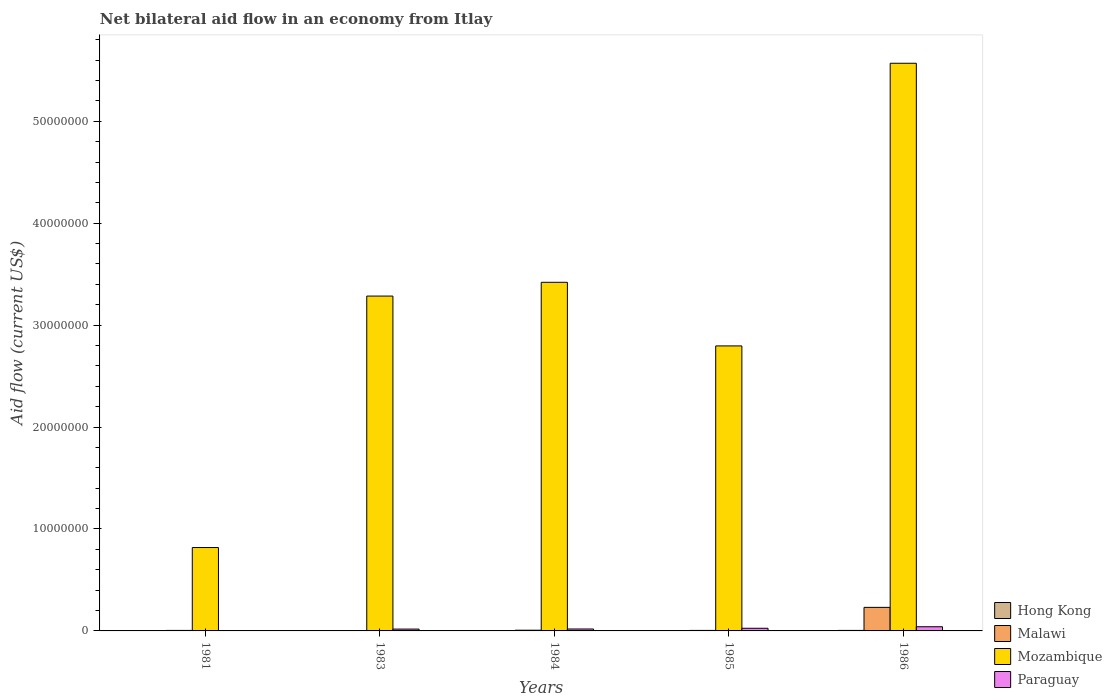How many different coloured bars are there?
Keep it short and to the point. 4. How many groups of bars are there?
Offer a very short reply. 5. Are the number of bars per tick equal to the number of legend labels?
Provide a succinct answer. Yes. How many bars are there on the 2nd tick from the right?
Your answer should be very brief. 4. What is the label of the 3rd group of bars from the left?
Offer a terse response. 1984. In how many cases, is the number of bars for a given year not equal to the number of legend labels?
Your answer should be compact. 0. Across all years, what is the minimum net bilateral aid flow in Hong Kong?
Give a very brief answer. 10000. In which year was the net bilateral aid flow in Paraguay minimum?
Provide a short and direct response. 1981. What is the total net bilateral aid flow in Hong Kong in the graph?
Provide a succinct answer. 1.10e+05. What is the difference between the net bilateral aid flow in Malawi in 1985 and that in 1986?
Provide a short and direct response. -2.26e+06. What is the difference between the net bilateral aid flow in Paraguay in 1986 and the net bilateral aid flow in Mozambique in 1985?
Keep it short and to the point. -2.76e+07. What is the average net bilateral aid flow in Hong Kong per year?
Provide a short and direct response. 2.20e+04. In the year 1985, what is the difference between the net bilateral aid flow in Paraguay and net bilateral aid flow in Mozambique?
Ensure brevity in your answer.  -2.77e+07. In how many years, is the net bilateral aid flow in Paraguay greater than 4000000 US$?
Ensure brevity in your answer.  0. Is the net bilateral aid flow in Paraguay in 1981 less than that in 1985?
Your answer should be compact. Yes. What is the difference between the highest and the lowest net bilateral aid flow in Mozambique?
Give a very brief answer. 4.75e+07. Is it the case that in every year, the sum of the net bilateral aid flow in Hong Kong and net bilateral aid flow in Paraguay is greater than the sum of net bilateral aid flow in Malawi and net bilateral aid flow in Mozambique?
Offer a very short reply. No. What does the 2nd bar from the left in 1984 represents?
Your response must be concise. Malawi. What does the 1st bar from the right in 1985 represents?
Your answer should be very brief. Paraguay. How many bars are there?
Provide a succinct answer. 20. Does the graph contain any zero values?
Make the answer very short. No. How many legend labels are there?
Your answer should be compact. 4. What is the title of the graph?
Offer a very short reply. Net bilateral aid flow in an economy from Itlay. What is the label or title of the Y-axis?
Your answer should be compact. Aid flow (current US$). What is the Aid flow (current US$) of Hong Kong in 1981?
Your response must be concise. 10000. What is the Aid flow (current US$) in Malawi in 1981?
Your answer should be very brief. 5.00e+04. What is the Aid flow (current US$) of Mozambique in 1981?
Your answer should be very brief. 8.18e+06. What is the Aid flow (current US$) of Paraguay in 1981?
Your response must be concise. 4.00e+04. What is the Aid flow (current US$) of Hong Kong in 1983?
Offer a very short reply. 2.00e+04. What is the Aid flow (current US$) of Mozambique in 1983?
Provide a succinct answer. 3.28e+07. What is the Aid flow (current US$) of Malawi in 1984?
Your response must be concise. 7.00e+04. What is the Aid flow (current US$) in Mozambique in 1984?
Provide a succinct answer. 3.42e+07. What is the Aid flow (current US$) of Hong Kong in 1985?
Your answer should be very brief. 10000. What is the Aid flow (current US$) in Mozambique in 1985?
Provide a short and direct response. 2.80e+07. What is the Aid flow (current US$) in Paraguay in 1985?
Ensure brevity in your answer.  2.60e+05. What is the Aid flow (current US$) of Malawi in 1986?
Offer a very short reply. 2.31e+06. What is the Aid flow (current US$) of Mozambique in 1986?
Your answer should be compact. 5.57e+07. Across all years, what is the maximum Aid flow (current US$) of Hong Kong?
Keep it short and to the point. 5.00e+04. Across all years, what is the maximum Aid flow (current US$) in Malawi?
Ensure brevity in your answer.  2.31e+06. Across all years, what is the maximum Aid flow (current US$) of Mozambique?
Your response must be concise. 5.57e+07. Across all years, what is the maximum Aid flow (current US$) of Paraguay?
Your response must be concise. 4.10e+05. Across all years, what is the minimum Aid flow (current US$) of Mozambique?
Keep it short and to the point. 8.18e+06. What is the total Aid flow (current US$) in Hong Kong in the graph?
Ensure brevity in your answer.  1.10e+05. What is the total Aid flow (current US$) of Malawi in the graph?
Keep it short and to the point. 2.50e+06. What is the total Aid flow (current US$) of Mozambique in the graph?
Offer a very short reply. 1.59e+08. What is the total Aid flow (current US$) in Paraguay in the graph?
Ensure brevity in your answer.  1.08e+06. What is the difference between the Aid flow (current US$) of Hong Kong in 1981 and that in 1983?
Make the answer very short. -10000. What is the difference between the Aid flow (current US$) in Malawi in 1981 and that in 1983?
Keep it short and to the point. 3.00e+04. What is the difference between the Aid flow (current US$) in Mozambique in 1981 and that in 1983?
Keep it short and to the point. -2.47e+07. What is the difference between the Aid flow (current US$) in Mozambique in 1981 and that in 1984?
Provide a short and direct response. -2.60e+07. What is the difference between the Aid flow (current US$) of Hong Kong in 1981 and that in 1985?
Provide a succinct answer. 0. What is the difference between the Aid flow (current US$) in Mozambique in 1981 and that in 1985?
Offer a very short reply. -1.98e+07. What is the difference between the Aid flow (current US$) of Paraguay in 1981 and that in 1985?
Give a very brief answer. -2.20e+05. What is the difference between the Aid flow (current US$) in Malawi in 1981 and that in 1986?
Your answer should be compact. -2.26e+06. What is the difference between the Aid flow (current US$) in Mozambique in 1981 and that in 1986?
Your answer should be very brief. -4.75e+07. What is the difference between the Aid flow (current US$) of Paraguay in 1981 and that in 1986?
Your answer should be compact. -3.70e+05. What is the difference between the Aid flow (current US$) in Hong Kong in 1983 and that in 1984?
Your answer should be compact. 0. What is the difference between the Aid flow (current US$) of Mozambique in 1983 and that in 1984?
Provide a short and direct response. -1.35e+06. What is the difference between the Aid flow (current US$) of Paraguay in 1983 and that in 1984?
Ensure brevity in your answer.  -10000. What is the difference between the Aid flow (current US$) of Malawi in 1983 and that in 1985?
Keep it short and to the point. -3.00e+04. What is the difference between the Aid flow (current US$) in Mozambique in 1983 and that in 1985?
Your response must be concise. 4.89e+06. What is the difference between the Aid flow (current US$) of Hong Kong in 1983 and that in 1986?
Make the answer very short. -3.00e+04. What is the difference between the Aid flow (current US$) of Malawi in 1983 and that in 1986?
Keep it short and to the point. -2.29e+06. What is the difference between the Aid flow (current US$) in Mozambique in 1983 and that in 1986?
Provide a short and direct response. -2.28e+07. What is the difference between the Aid flow (current US$) of Paraguay in 1983 and that in 1986?
Offer a terse response. -2.30e+05. What is the difference between the Aid flow (current US$) in Malawi in 1984 and that in 1985?
Your response must be concise. 2.00e+04. What is the difference between the Aid flow (current US$) of Mozambique in 1984 and that in 1985?
Keep it short and to the point. 6.24e+06. What is the difference between the Aid flow (current US$) of Hong Kong in 1984 and that in 1986?
Give a very brief answer. -3.00e+04. What is the difference between the Aid flow (current US$) in Malawi in 1984 and that in 1986?
Provide a succinct answer. -2.24e+06. What is the difference between the Aid flow (current US$) of Mozambique in 1984 and that in 1986?
Make the answer very short. -2.15e+07. What is the difference between the Aid flow (current US$) in Paraguay in 1984 and that in 1986?
Give a very brief answer. -2.20e+05. What is the difference between the Aid flow (current US$) in Malawi in 1985 and that in 1986?
Your answer should be very brief. -2.26e+06. What is the difference between the Aid flow (current US$) of Mozambique in 1985 and that in 1986?
Keep it short and to the point. -2.77e+07. What is the difference between the Aid flow (current US$) of Paraguay in 1985 and that in 1986?
Make the answer very short. -1.50e+05. What is the difference between the Aid flow (current US$) in Hong Kong in 1981 and the Aid flow (current US$) in Mozambique in 1983?
Your answer should be compact. -3.28e+07. What is the difference between the Aid flow (current US$) in Hong Kong in 1981 and the Aid flow (current US$) in Paraguay in 1983?
Ensure brevity in your answer.  -1.70e+05. What is the difference between the Aid flow (current US$) of Malawi in 1981 and the Aid flow (current US$) of Mozambique in 1983?
Keep it short and to the point. -3.28e+07. What is the difference between the Aid flow (current US$) of Hong Kong in 1981 and the Aid flow (current US$) of Mozambique in 1984?
Your answer should be compact. -3.42e+07. What is the difference between the Aid flow (current US$) of Hong Kong in 1981 and the Aid flow (current US$) of Paraguay in 1984?
Provide a short and direct response. -1.80e+05. What is the difference between the Aid flow (current US$) in Malawi in 1981 and the Aid flow (current US$) in Mozambique in 1984?
Make the answer very short. -3.42e+07. What is the difference between the Aid flow (current US$) in Mozambique in 1981 and the Aid flow (current US$) in Paraguay in 1984?
Offer a very short reply. 7.99e+06. What is the difference between the Aid flow (current US$) of Hong Kong in 1981 and the Aid flow (current US$) of Malawi in 1985?
Provide a short and direct response. -4.00e+04. What is the difference between the Aid flow (current US$) of Hong Kong in 1981 and the Aid flow (current US$) of Mozambique in 1985?
Keep it short and to the point. -2.80e+07. What is the difference between the Aid flow (current US$) of Malawi in 1981 and the Aid flow (current US$) of Mozambique in 1985?
Ensure brevity in your answer.  -2.79e+07. What is the difference between the Aid flow (current US$) of Mozambique in 1981 and the Aid flow (current US$) of Paraguay in 1985?
Your answer should be compact. 7.92e+06. What is the difference between the Aid flow (current US$) of Hong Kong in 1981 and the Aid flow (current US$) of Malawi in 1986?
Give a very brief answer. -2.30e+06. What is the difference between the Aid flow (current US$) in Hong Kong in 1981 and the Aid flow (current US$) in Mozambique in 1986?
Make the answer very short. -5.57e+07. What is the difference between the Aid flow (current US$) in Hong Kong in 1981 and the Aid flow (current US$) in Paraguay in 1986?
Your response must be concise. -4.00e+05. What is the difference between the Aid flow (current US$) in Malawi in 1981 and the Aid flow (current US$) in Mozambique in 1986?
Offer a terse response. -5.56e+07. What is the difference between the Aid flow (current US$) of Malawi in 1981 and the Aid flow (current US$) of Paraguay in 1986?
Keep it short and to the point. -3.60e+05. What is the difference between the Aid flow (current US$) in Mozambique in 1981 and the Aid flow (current US$) in Paraguay in 1986?
Offer a very short reply. 7.77e+06. What is the difference between the Aid flow (current US$) in Hong Kong in 1983 and the Aid flow (current US$) in Mozambique in 1984?
Make the answer very short. -3.42e+07. What is the difference between the Aid flow (current US$) in Hong Kong in 1983 and the Aid flow (current US$) in Paraguay in 1984?
Provide a short and direct response. -1.70e+05. What is the difference between the Aid flow (current US$) of Malawi in 1983 and the Aid flow (current US$) of Mozambique in 1984?
Your answer should be compact. -3.42e+07. What is the difference between the Aid flow (current US$) of Malawi in 1983 and the Aid flow (current US$) of Paraguay in 1984?
Offer a very short reply. -1.70e+05. What is the difference between the Aid flow (current US$) in Mozambique in 1983 and the Aid flow (current US$) in Paraguay in 1984?
Ensure brevity in your answer.  3.27e+07. What is the difference between the Aid flow (current US$) of Hong Kong in 1983 and the Aid flow (current US$) of Mozambique in 1985?
Your answer should be compact. -2.79e+07. What is the difference between the Aid flow (current US$) in Hong Kong in 1983 and the Aid flow (current US$) in Paraguay in 1985?
Your answer should be very brief. -2.40e+05. What is the difference between the Aid flow (current US$) of Malawi in 1983 and the Aid flow (current US$) of Mozambique in 1985?
Your response must be concise. -2.79e+07. What is the difference between the Aid flow (current US$) in Mozambique in 1983 and the Aid flow (current US$) in Paraguay in 1985?
Ensure brevity in your answer.  3.26e+07. What is the difference between the Aid flow (current US$) of Hong Kong in 1983 and the Aid flow (current US$) of Malawi in 1986?
Your answer should be very brief. -2.29e+06. What is the difference between the Aid flow (current US$) of Hong Kong in 1983 and the Aid flow (current US$) of Mozambique in 1986?
Your response must be concise. -5.57e+07. What is the difference between the Aid flow (current US$) in Hong Kong in 1983 and the Aid flow (current US$) in Paraguay in 1986?
Make the answer very short. -3.90e+05. What is the difference between the Aid flow (current US$) in Malawi in 1983 and the Aid flow (current US$) in Mozambique in 1986?
Ensure brevity in your answer.  -5.57e+07. What is the difference between the Aid flow (current US$) in Malawi in 1983 and the Aid flow (current US$) in Paraguay in 1986?
Make the answer very short. -3.90e+05. What is the difference between the Aid flow (current US$) in Mozambique in 1983 and the Aid flow (current US$) in Paraguay in 1986?
Give a very brief answer. 3.24e+07. What is the difference between the Aid flow (current US$) of Hong Kong in 1984 and the Aid flow (current US$) of Malawi in 1985?
Your response must be concise. -3.00e+04. What is the difference between the Aid flow (current US$) of Hong Kong in 1984 and the Aid flow (current US$) of Mozambique in 1985?
Your response must be concise. -2.79e+07. What is the difference between the Aid flow (current US$) in Malawi in 1984 and the Aid flow (current US$) in Mozambique in 1985?
Provide a short and direct response. -2.79e+07. What is the difference between the Aid flow (current US$) in Malawi in 1984 and the Aid flow (current US$) in Paraguay in 1985?
Your answer should be compact. -1.90e+05. What is the difference between the Aid flow (current US$) of Mozambique in 1984 and the Aid flow (current US$) of Paraguay in 1985?
Offer a terse response. 3.39e+07. What is the difference between the Aid flow (current US$) in Hong Kong in 1984 and the Aid flow (current US$) in Malawi in 1986?
Your answer should be very brief. -2.29e+06. What is the difference between the Aid flow (current US$) in Hong Kong in 1984 and the Aid flow (current US$) in Mozambique in 1986?
Provide a short and direct response. -5.57e+07. What is the difference between the Aid flow (current US$) of Hong Kong in 1984 and the Aid flow (current US$) of Paraguay in 1986?
Make the answer very short. -3.90e+05. What is the difference between the Aid flow (current US$) in Malawi in 1984 and the Aid flow (current US$) in Mozambique in 1986?
Your answer should be very brief. -5.56e+07. What is the difference between the Aid flow (current US$) of Mozambique in 1984 and the Aid flow (current US$) of Paraguay in 1986?
Your response must be concise. 3.38e+07. What is the difference between the Aid flow (current US$) of Hong Kong in 1985 and the Aid flow (current US$) of Malawi in 1986?
Give a very brief answer. -2.30e+06. What is the difference between the Aid flow (current US$) in Hong Kong in 1985 and the Aid flow (current US$) in Mozambique in 1986?
Offer a very short reply. -5.57e+07. What is the difference between the Aid flow (current US$) of Hong Kong in 1985 and the Aid flow (current US$) of Paraguay in 1986?
Your answer should be very brief. -4.00e+05. What is the difference between the Aid flow (current US$) of Malawi in 1985 and the Aid flow (current US$) of Mozambique in 1986?
Ensure brevity in your answer.  -5.56e+07. What is the difference between the Aid flow (current US$) of Malawi in 1985 and the Aid flow (current US$) of Paraguay in 1986?
Your answer should be compact. -3.60e+05. What is the difference between the Aid flow (current US$) in Mozambique in 1985 and the Aid flow (current US$) in Paraguay in 1986?
Offer a terse response. 2.76e+07. What is the average Aid flow (current US$) in Hong Kong per year?
Provide a succinct answer. 2.20e+04. What is the average Aid flow (current US$) in Malawi per year?
Offer a terse response. 5.00e+05. What is the average Aid flow (current US$) of Mozambique per year?
Provide a short and direct response. 3.18e+07. What is the average Aid flow (current US$) of Paraguay per year?
Give a very brief answer. 2.16e+05. In the year 1981, what is the difference between the Aid flow (current US$) of Hong Kong and Aid flow (current US$) of Malawi?
Provide a short and direct response. -4.00e+04. In the year 1981, what is the difference between the Aid flow (current US$) in Hong Kong and Aid flow (current US$) in Mozambique?
Make the answer very short. -8.17e+06. In the year 1981, what is the difference between the Aid flow (current US$) of Malawi and Aid flow (current US$) of Mozambique?
Your answer should be very brief. -8.13e+06. In the year 1981, what is the difference between the Aid flow (current US$) in Mozambique and Aid flow (current US$) in Paraguay?
Keep it short and to the point. 8.14e+06. In the year 1983, what is the difference between the Aid flow (current US$) in Hong Kong and Aid flow (current US$) in Mozambique?
Your response must be concise. -3.28e+07. In the year 1983, what is the difference between the Aid flow (current US$) in Hong Kong and Aid flow (current US$) in Paraguay?
Your answer should be compact. -1.60e+05. In the year 1983, what is the difference between the Aid flow (current US$) of Malawi and Aid flow (current US$) of Mozambique?
Offer a very short reply. -3.28e+07. In the year 1983, what is the difference between the Aid flow (current US$) of Mozambique and Aid flow (current US$) of Paraguay?
Offer a terse response. 3.27e+07. In the year 1984, what is the difference between the Aid flow (current US$) in Hong Kong and Aid flow (current US$) in Mozambique?
Your response must be concise. -3.42e+07. In the year 1984, what is the difference between the Aid flow (current US$) of Hong Kong and Aid flow (current US$) of Paraguay?
Keep it short and to the point. -1.70e+05. In the year 1984, what is the difference between the Aid flow (current US$) of Malawi and Aid flow (current US$) of Mozambique?
Ensure brevity in your answer.  -3.41e+07. In the year 1984, what is the difference between the Aid flow (current US$) in Malawi and Aid flow (current US$) in Paraguay?
Your response must be concise. -1.20e+05. In the year 1984, what is the difference between the Aid flow (current US$) of Mozambique and Aid flow (current US$) of Paraguay?
Provide a succinct answer. 3.40e+07. In the year 1985, what is the difference between the Aid flow (current US$) of Hong Kong and Aid flow (current US$) of Malawi?
Your response must be concise. -4.00e+04. In the year 1985, what is the difference between the Aid flow (current US$) of Hong Kong and Aid flow (current US$) of Mozambique?
Keep it short and to the point. -2.80e+07. In the year 1985, what is the difference between the Aid flow (current US$) in Hong Kong and Aid flow (current US$) in Paraguay?
Your response must be concise. -2.50e+05. In the year 1985, what is the difference between the Aid flow (current US$) in Malawi and Aid flow (current US$) in Mozambique?
Offer a very short reply. -2.79e+07. In the year 1985, what is the difference between the Aid flow (current US$) in Mozambique and Aid flow (current US$) in Paraguay?
Provide a short and direct response. 2.77e+07. In the year 1986, what is the difference between the Aid flow (current US$) in Hong Kong and Aid flow (current US$) in Malawi?
Provide a short and direct response. -2.26e+06. In the year 1986, what is the difference between the Aid flow (current US$) of Hong Kong and Aid flow (current US$) of Mozambique?
Provide a short and direct response. -5.56e+07. In the year 1986, what is the difference between the Aid flow (current US$) of Hong Kong and Aid flow (current US$) of Paraguay?
Provide a succinct answer. -3.60e+05. In the year 1986, what is the difference between the Aid flow (current US$) in Malawi and Aid flow (current US$) in Mozambique?
Make the answer very short. -5.34e+07. In the year 1986, what is the difference between the Aid flow (current US$) of Malawi and Aid flow (current US$) of Paraguay?
Ensure brevity in your answer.  1.90e+06. In the year 1986, what is the difference between the Aid flow (current US$) in Mozambique and Aid flow (current US$) in Paraguay?
Provide a succinct answer. 5.53e+07. What is the ratio of the Aid flow (current US$) of Malawi in 1981 to that in 1983?
Your response must be concise. 2.5. What is the ratio of the Aid flow (current US$) in Mozambique in 1981 to that in 1983?
Provide a short and direct response. 0.25. What is the ratio of the Aid flow (current US$) in Paraguay in 1981 to that in 1983?
Your response must be concise. 0.22. What is the ratio of the Aid flow (current US$) in Mozambique in 1981 to that in 1984?
Provide a short and direct response. 0.24. What is the ratio of the Aid flow (current US$) in Paraguay in 1981 to that in 1984?
Ensure brevity in your answer.  0.21. What is the ratio of the Aid flow (current US$) in Malawi in 1981 to that in 1985?
Provide a succinct answer. 1. What is the ratio of the Aid flow (current US$) in Mozambique in 1981 to that in 1985?
Your response must be concise. 0.29. What is the ratio of the Aid flow (current US$) in Paraguay in 1981 to that in 1985?
Offer a terse response. 0.15. What is the ratio of the Aid flow (current US$) in Malawi in 1981 to that in 1986?
Your response must be concise. 0.02. What is the ratio of the Aid flow (current US$) in Mozambique in 1981 to that in 1986?
Make the answer very short. 0.15. What is the ratio of the Aid flow (current US$) of Paraguay in 1981 to that in 1986?
Offer a terse response. 0.1. What is the ratio of the Aid flow (current US$) in Hong Kong in 1983 to that in 1984?
Your response must be concise. 1. What is the ratio of the Aid flow (current US$) in Malawi in 1983 to that in 1984?
Make the answer very short. 0.29. What is the ratio of the Aid flow (current US$) in Mozambique in 1983 to that in 1984?
Offer a terse response. 0.96. What is the ratio of the Aid flow (current US$) in Paraguay in 1983 to that in 1984?
Offer a very short reply. 0.95. What is the ratio of the Aid flow (current US$) in Hong Kong in 1983 to that in 1985?
Keep it short and to the point. 2. What is the ratio of the Aid flow (current US$) in Mozambique in 1983 to that in 1985?
Offer a terse response. 1.17. What is the ratio of the Aid flow (current US$) in Paraguay in 1983 to that in 1985?
Make the answer very short. 0.69. What is the ratio of the Aid flow (current US$) in Malawi in 1983 to that in 1986?
Make the answer very short. 0.01. What is the ratio of the Aid flow (current US$) of Mozambique in 1983 to that in 1986?
Your answer should be compact. 0.59. What is the ratio of the Aid flow (current US$) of Paraguay in 1983 to that in 1986?
Provide a succinct answer. 0.44. What is the ratio of the Aid flow (current US$) of Hong Kong in 1984 to that in 1985?
Your answer should be very brief. 2. What is the ratio of the Aid flow (current US$) in Mozambique in 1984 to that in 1985?
Ensure brevity in your answer.  1.22. What is the ratio of the Aid flow (current US$) of Paraguay in 1984 to that in 1985?
Offer a terse response. 0.73. What is the ratio of the Aid flow (current US$) of Hong Kong in 1984 to that in 1986?
Your answer should be very brief. 0.4. What is the ratio of the Aid flow (current US$) of Malawi in 1984 to that in 1986?
Make the answer very short. 0.03. What is the ratio of the Aid flow (current US$) in Mozambique in 1984 to that in 1986?
Give a very brief answer. 0.61. What is the ratio of the Aid flow (current US$) in Paraguay in 1984 to that in 1986?
Provide a succinct answer. 0.46. What is the ratio of the Aid flow (current US$) of Hong Kong in 1985 to that in 1986?
Provide a succinct answer. 0.2. What is the ratio of the Aid flow (current US$) in Malawi in 1985 to that in 1986?
Keep it short and to the point. 0.02. What is the ratio of the Aid flow (current US$) of Mozambique in 1985 to that in 1986?
Give a very brief answer. 0.5. What is the ratio of the Aid flow (current US$) of Paraguay in 1985 to that in 1986?
Your response must be concise. 0.63. What is the difference between the highest and the second highest Aid flow (current US$) in Hong Kong?
Offer a terse response. 3.00e+04. What is the difference between the highest and the second highest Aid flow (current US$) in Malawi?
Provide a short and direct response. 2.24e+06. What is the difference between the highest and the second highest Aid flow (current US$) in Mozambique?
Your answer should be very brief. 2.15e+07. What is the difference between the highest and the lowest Aid flow (current US$) of Malawi?
Your answer should be very brief. 2.29e+06. What is the difference between the highest and the lowest Aid flow (current US$) of Mozambique?
Provide a succinct answer. 4.75e+07. What is the difference between the highest and the lowest Aid flow (current US$) of Paraguay?
Give a very brief answer. 3.70e+05. 